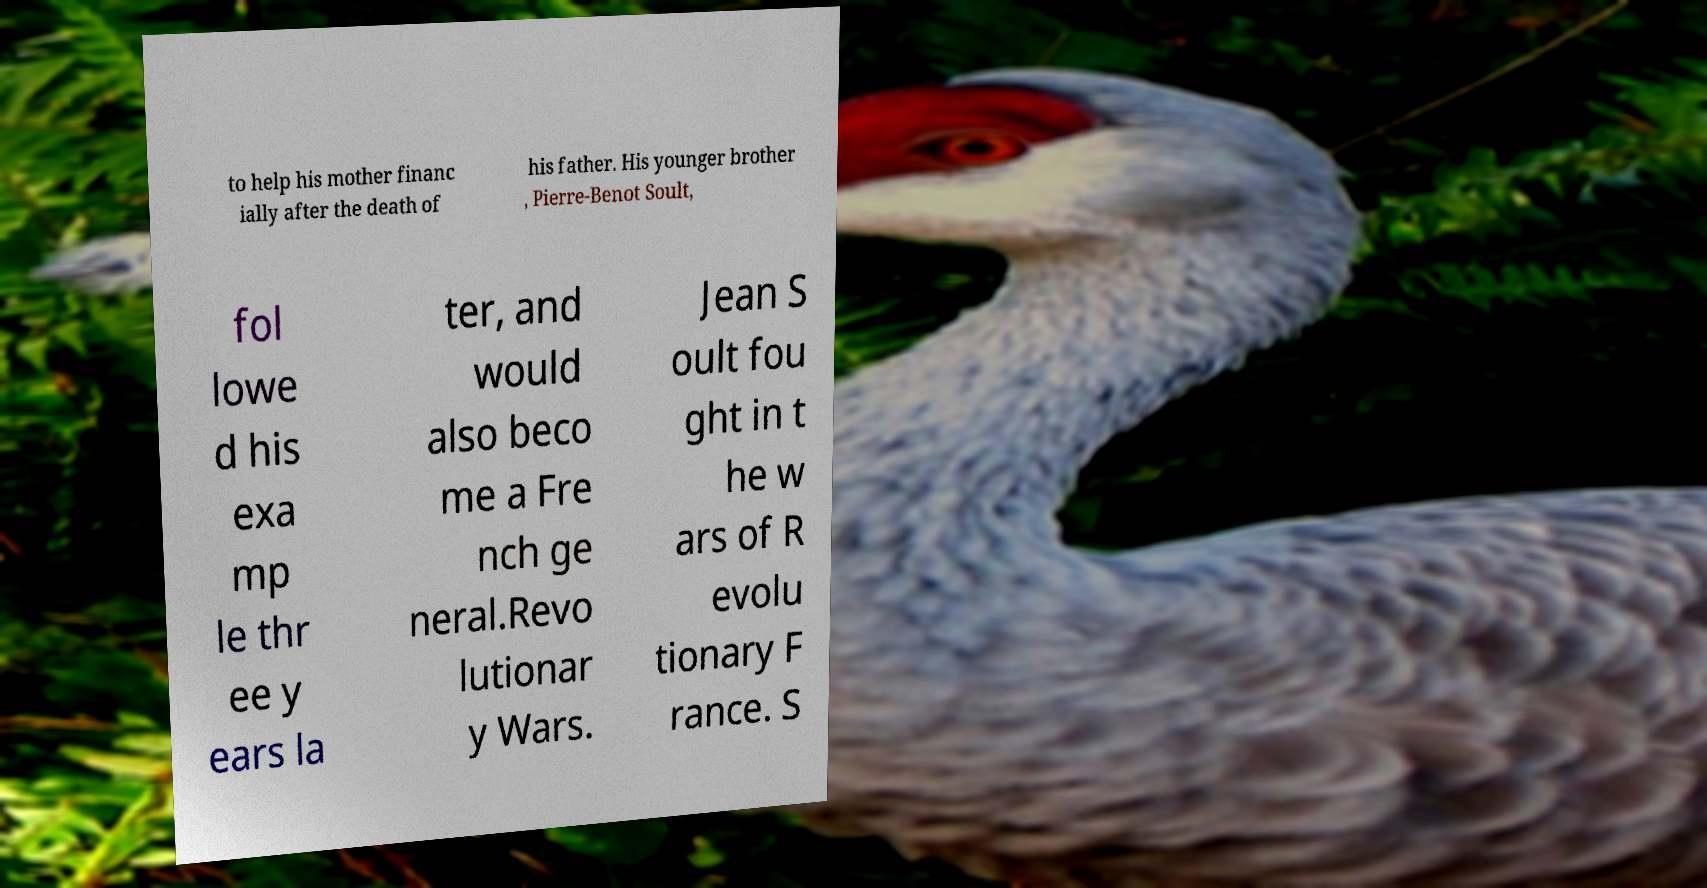Can you read and provide the text displayed in the image?This photo seems to have some interesting text. Can you extract and type it out for me? to help his mother financ ially after the death of his father. His younger brother , Pierre-Benot Soult, fol lowe d his exa mp le thr ee y ears la ter, and would also beco me a Fre nch ge neral.Revo lutionar y Wars. Jean S oult fou ght in t he w ars of R evolu tionary F rance. S 